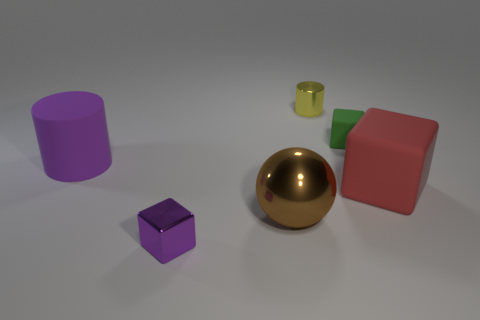Are there any other things that are the same shape as the large brown thing?
Ensure brevity in your answer.  No. What shape is the large matte thing that is to the right of the large rubber object that is to the left of the small thing left of the big brown thing?
Give a very brief answer. Cube. There is a yellow metallic cylinder; is its size the same as the matte object on the left side of the yellow shiny cylinder?
Offer a terse response. No. There is a large object that is on the left side of the yellow shiny cylinder and on the right side of the big matte cylinder; what is its color?
Make the answer very short. Brown. How many other things are there of the same shape as the tiny yellow metallic object?
Give a very brief answer. 1. There is a big matte thing behind the big red rubber block; is its color the same as the tiny cube that is on the left side of the brown sphere?
Keep it short and to the point. Yes. Is the size of the matte object left of the yellow metal cylinder the same as the thing that is in front of the large shiny thing?
Make the answer very short. No. The cylinder that is to the right of the big rubber object that is on the left side of the cube that is in front of the big red block is made of what material?
Make the answer very short. Metal. Is the green thing the same shape as the big brown metal object?
Keep it short and to the point. No. There is a green thing that is the same shape as the large red rubber thing; what is it made of?
Keep it short and to the point. Rubber. 